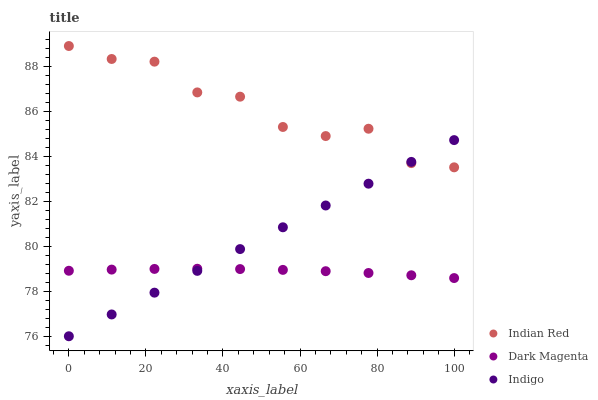Does Dark Magenta have the minimum area under the curve?
Answer yes or no. Yes. Does Indian Red have the maximum area under the curve?
Answer yes or no. Yes. Does Indian Red have the minimum area under the curve?
Answer yes or no. No. Does Dark Magenta have the maximum area under the curve?
Answer yes or no. No. Is Indigo the smoothest?
Answer yes or no. Yes. Is Indian Red the roughest?
Answer yes or no. Yes. Is Dark Magenta the smoothest?
Answer yes or no. No. Is Dark Magenta the roughest?
Answer yes or no. No. Does Indigo have the lowest value?
Answer yes or no. Yes. Does Dark Magenta have the lowest value?
Answer yes or no. No. Does Indian Red have the highest value?
Answer yes or no. Yes. Does Dark Magenta have the highest value?
Answer yes or no. No. Is Dark Magenta less than Indian Red?
Answer yes or no. Yes. Is Indian Red greater than Dark Magenta?
Answer yes or no. Yes. Does Indian Red intersect Indigo?
Answer yes or no. Yes. Is Indian Red less than Indigo?
Answer yes or no. No. Is Indian Red greater than Indigo?
Answer yes or no. No. Does Dark Magenta intersect Indian Red?
Answer yes or no. No. 